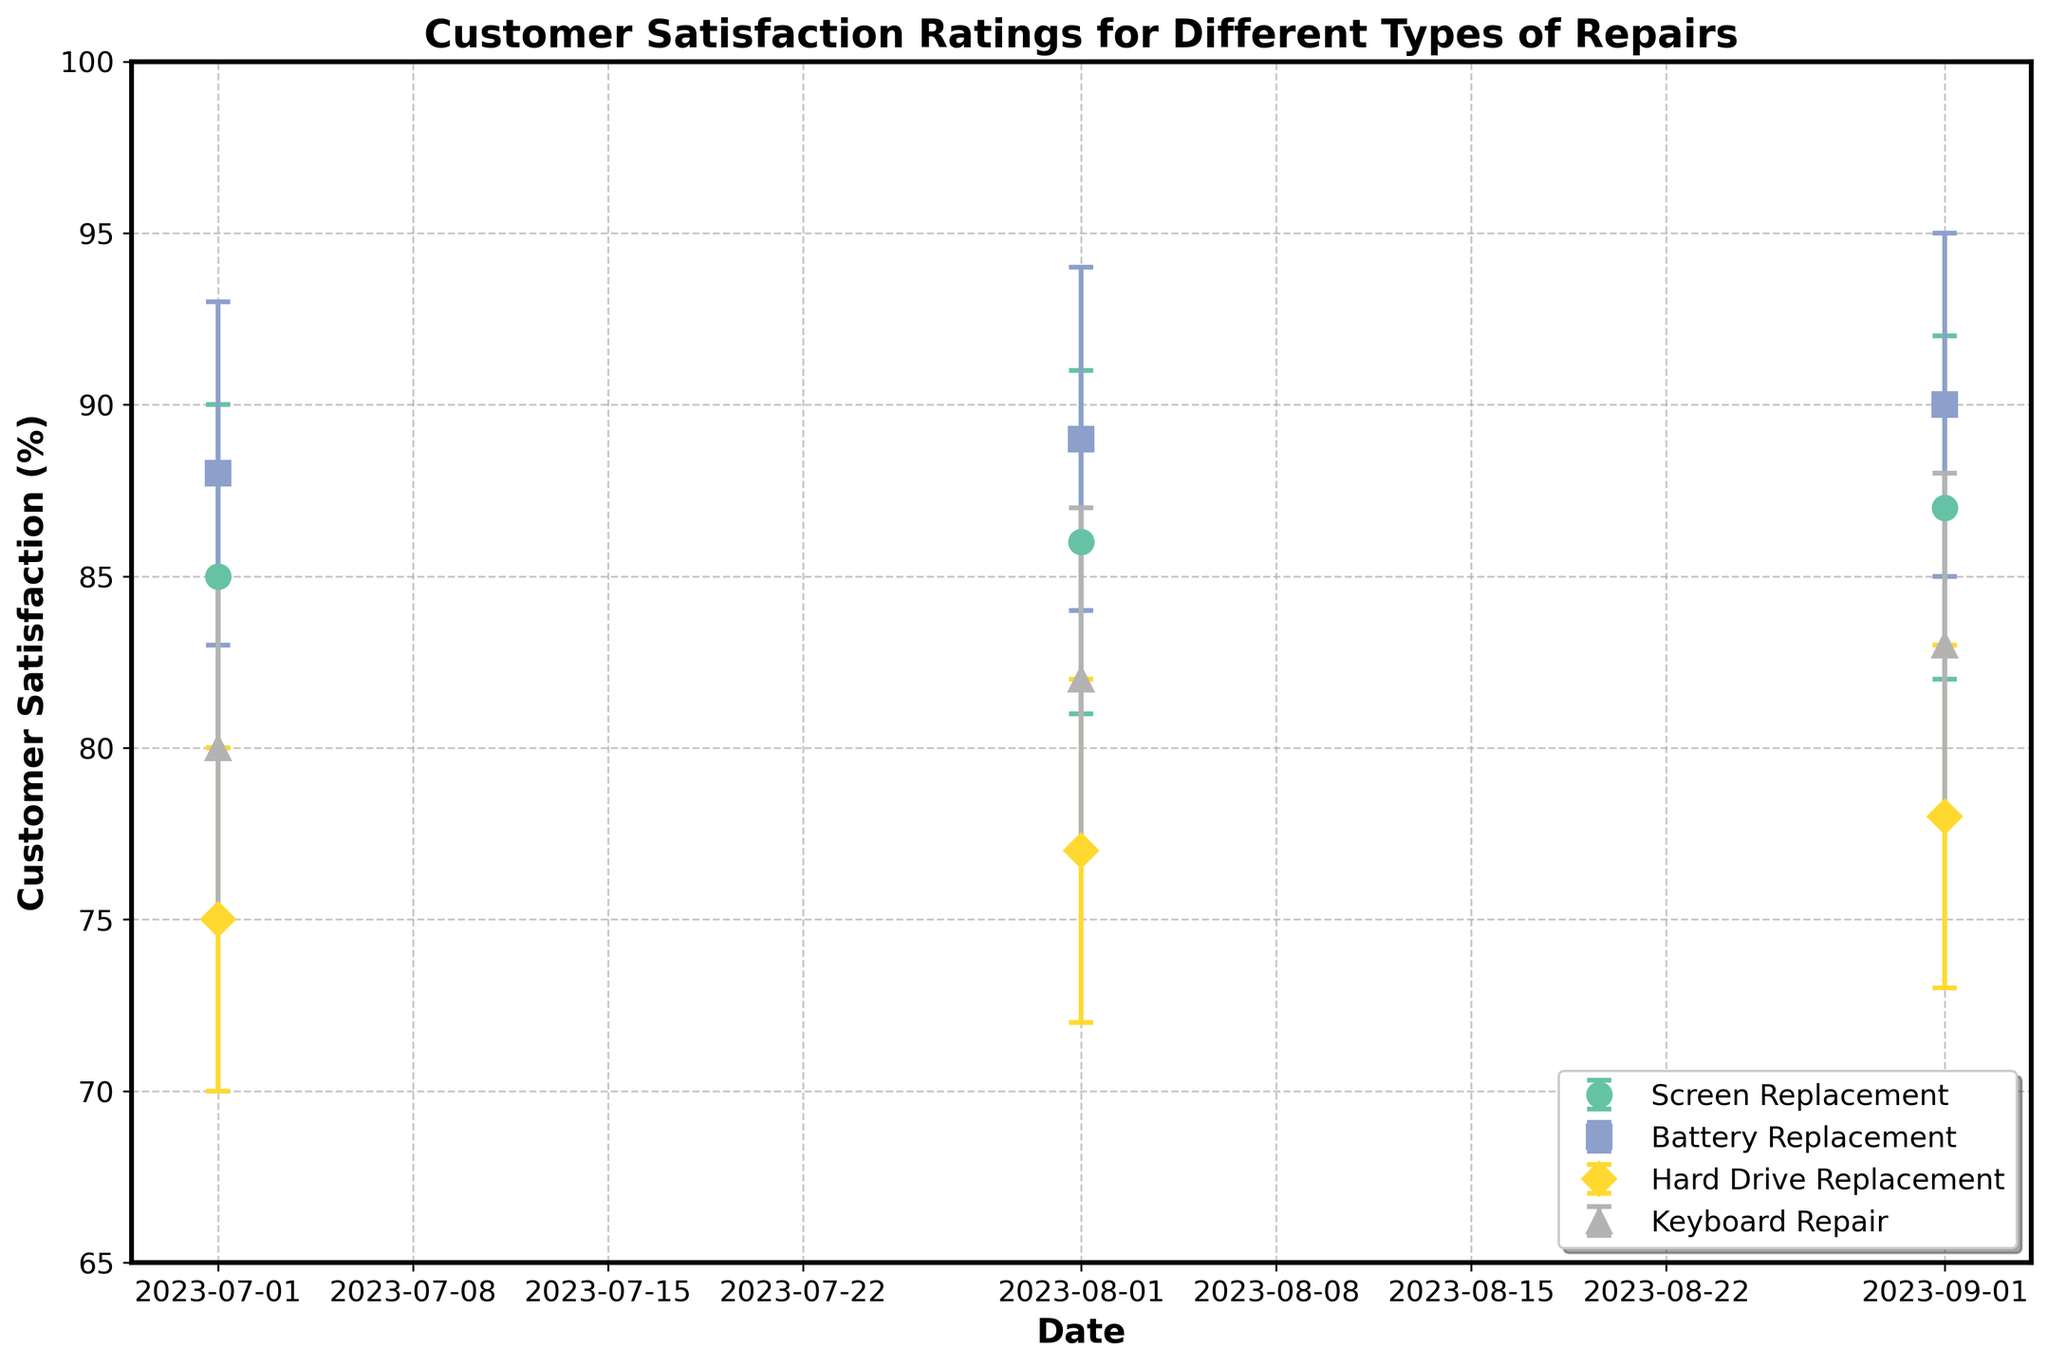What's the highest customer satisfaction rating for Screen Replacement? The highest customer satisfaction rating for Screen Replacement is displayed on the September 1st data point with a value of 87%.
Answer: 87% On which date did Keyboard Repair have the lowest customer satisfaction rating? By looking at the data points for Keyboard Repair on each date, the lowest rating is found on July 1st with a value of 80%.
Answer: July 1st How much did the customer satisfaction for Battery Replacement increase from July to September? The customer satisfaction for Battery Replacement was 88% in July and increased to 90% in September, resulting in an increase of 90% - 88% = 2%.
Answer: 2% Which type of repair had the smallest confidence interval in August? Confidence intervals are represented by the error bars. For August, the type of repair where the error bars are shortest is Battery Replacement, with intervals 89-84 and 94-89, both showing a span of 5%.
Answer: Battery Replacement Did any type of repair have a decreasing trend in customer satisfaction over the quarter? By examining the trend lines, Hard Drive Replacement shows a steady increase in customer satisfaction from 75% to 78%, indicating no decrease. All other types of repair show an increasing trend too.
Answer: No Which type of repair had the greatest improvement in customer satisfaction between July and September? By comparing the satisfaction ratings, Screen Replacement increased from 85% to 87%, Battery Replacement from 88% to 90%, Hard Drive Replacement from 75% to 78%, and Keyboard Repair from 80% to 83%. Screen Replacement and Battery Replacement both improved by 2%, and Keyboard Repair improved by 3%.
Answer: Keyboard Repair What's the average customer satisfaction for all types of repairs in August? Adding all the customer satisfaction values for August: 86% (Screen Replacement), 89% (Battery Replacement), 77% (Hard Drive Replacement), and 82% (Keyboard Repair), then dividing by 4 gives (86+89+77+82)/4 = 83.5%.
Answer: 83.5% How do confidence intervals for Screen Replacement in September compare to those in July? In July, the confidence interval for Screen Replacement is from 80% to 90% (range of 10%). In September, it is from 82% to 92% (range of 10%). Both have the same range.
Answer: Same Is the increase in customer satisfaction for Hard Drive Replacement consistent over the three months? By checking the satisfaction ratings for Hard Drive Replacement: 75% in July, 77% in August, 78% in September, we see a consistent monthly increase.
Answer: Yes Which date and type of repair combination has the narrowest confidence interval throughout the data? Examining all confidence intervals, Battery Replacement in August has the narrowest interval with a range of 5% (from 84% to 94%).
Answer: Battery Replacement in August 